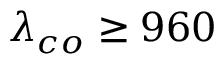<formula> <loc_0><loc_0><loc_500><loc_500>\lambda _ { c o } \geq 9 6 0</formula> 